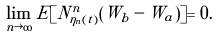Convert formula to latex. <formula><loc_0><loc_0><loc_500><loc_500>\lim _ { n \rightarrow \infty } E [ N ^ { n } _ { \eta _ { n } ( t ) } ( W _ { b } - W _ { a } ) ] = 0 .</formula> 